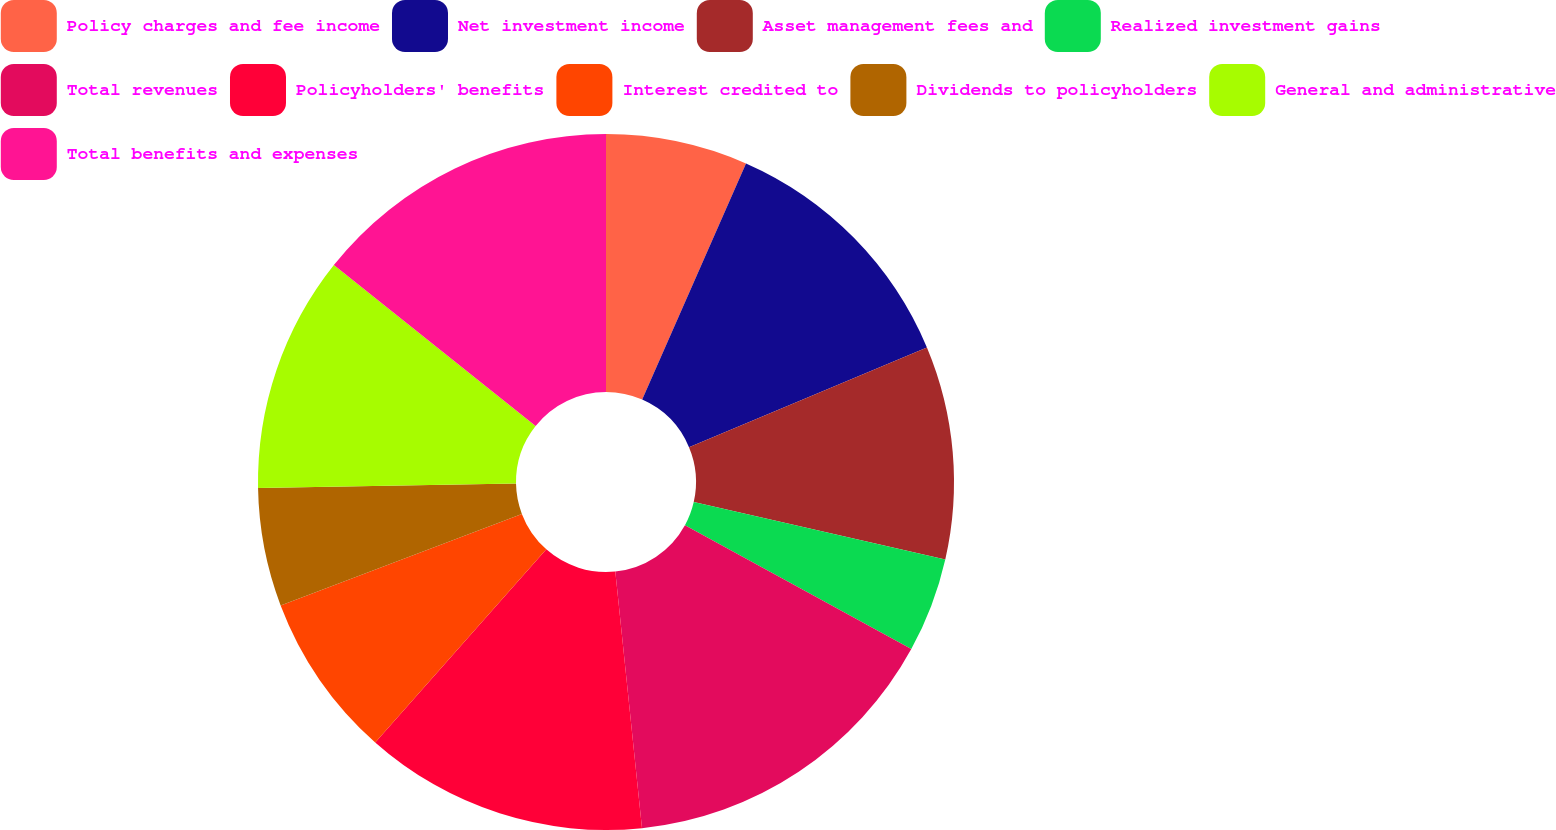<chart> <loc_0><loc_0><loc_500><loc_500><pie_chart><fcel>Policy charges and fee income<fcel>Net investment income<fcel>Asset management fees and<fcel>Realized investment gains<fcel>Total revenues<fcel>Policyholders' benefits<fcel>Interest credited to<fcel>Dividends to policyholders<fcel>General and administrative<fcel>Total benefits and expenses<nl><fcel>6.59%<fcel>12.09%<fcel>9.89%<fcel>4.4%<fcel>15.38%<fcel>13.19%<fcel>7.69%<fcel>5.49%<fcel>10.99%<fcel>14.29%<nl></chart> 